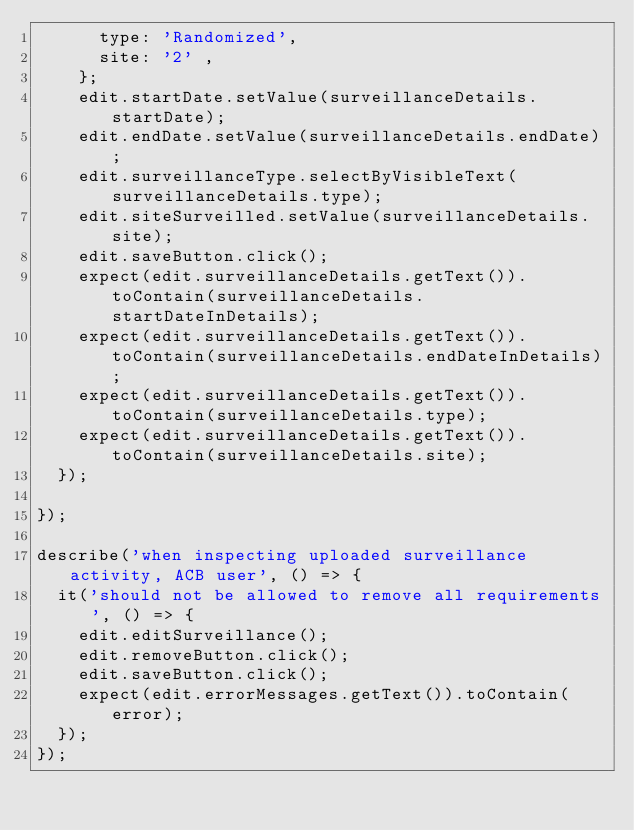<code> <loc_0><loc_0><loc_500><loc_500><_JavaScript_>      type: 'Randomized',
      site: '2' ,
    };
    edit.startDate.setValue(surveillanceDetails.startDate);
    edit.endDate.setValue(surveillanceDetails.endDate);
    edit.surveillanceType.selectByVisibleText(surveillanceDetails.type);
    edit.siteSurveilled.setValue(surveillanceDetails.site);
    edit.saveButton.click();
    expect(edit.surveillanceDetails.getText()).toContain(surveillanceDetails.startDateInDetails);
    expect(edit.surveillanceDetails.getText()).toContain(surveillanceDetails.endDateInDetails);
    expect(edit.surveillanceDetails.getText()).toContain(surveillanceDetails.type);
    expect(edit.surveillanceDetails.getText()).toContain(surveillanceDetails.site);
  });

});

describe('when inspecting uploaded surveillance activity, ACB user', () => {
  it('should not be allowed to remove all requirements', () => {
    edit.editSurveillance();
    edit.removeButton.click();
    edit.saveButton.click();
    expect(edit.errorMessages.getText()).toContain(error);
  });
});
</code> 